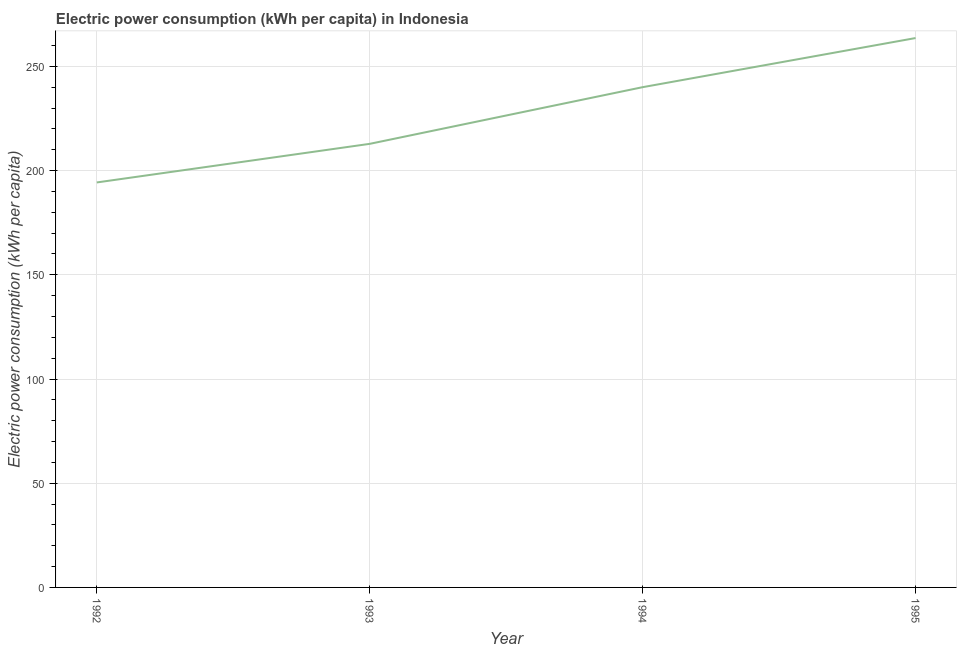What is the electric power consumption in 1995?
Offer a very short reply. 263.59. Across all years, what is the maximum electric power consumption?
Offer a very short reply. 263.59. Across all years, what is the minimum electric power consumption?
Your answer should be very brief. 194.31. In which year was the electric power consumption maximum?
Your answer should be very brief. 1995. What is the sum of the electric power consumption?
Offer a terse response. 910.74. What is the difference between the electric power consumption in 1992 and 1994?
Keep it short and to the point. -45.71. What is the average electric power consumption per year?
Your response must be concise. 227.69. What is the median electric power consumption?
Ensure brevity in your answer.  226.42. What is the ratio of the electric power consumption in 1993 to that in 1995?
Your answer should be very brief. 0.81. Is the difference between the electric power consumption in 1992 and 1994 greater than the difference between any two years?
Provide a succinct answer. No. What is the difference between the highest and the second highest electric power consumption?
Offer a terse response. 23.57. What is the difference between the highest and the lowest electric power consumption?
Offer a very short reply. 69.28. In how many years, is the electric power consumption greater than the average electric power consumption taken over all years?
Your answer should be very brief. 2. Does the electric power consumption monotonically increase over the years?
Provide a short and direct response. Yes. How many lines are there?
Give a very brief answer. 1. What is the difference between two consecutive major ticks on the Y-axis?
Provide a short and direct response. 50. Are the values on the major ticks of Y-axis written in scientific E-notation?
Make the answer very short. No. What is the title of the graph?
Give a very brief answer. Electric power consumption (kWh per capita) in Indonesia. What is the label or title of the Y-axis?
Your answer should be compact. Electric power consumption (kWh per capita). What is the Electric power consumption (kWh per capita) in 1992?
Your answer should be very brief. 194.31. What is the Electric power consumption (kWh per capita) of 1993?
Give a very brief answer. 212.83. What is the Electric power consumption (kWh per capita) of 1994?
Your answer should be compact. 240.02. What is the Electric power consumption (kWh per capita) in 1995?
Offer a terse response. 263.59. What is the difference between the Electric power consumption (kWh per capita) in 1992 and 1993?
Provide a succinct answer. -18.52. What is the difference between the Electric power consumption (kWh per capita) in 1992 and 1994?
Provide a short and direct response. -45.71. What is the difference between the Electric power consumption (kWh per capita) in 1992 and 1995?
Offer a very short reply. -69.28. What is the difference between the Electric power consumption (kWh per capita) in 1993 and 1994?
Provide a succinct answer. -27.19. What is the difference between the Electric power consumption (kWh per capita) in 1993 and 1995?
Your answer should be compact. -50.76. What is the difference between the Electric power consumption (kWh per capita) in 1994 and 1995?
Make the answer very short. -23.57. What is the ratio of the Electric power consumption (kWh per capita) in 1992 to that in 1994?
Keep it short and to the point. 0.81. What is the ratio of the Electric power consumption (kWh per capita) in 1992 to that in 1995?
Give a very brief answer. 0.74. What is the ratio of the Electric power consumption (kWh per capita) in 1993 to that in 1994?
Provide a short and direct response. 0.89. What is the ratio of the Electric power consumption (kWh per capita) in 1993 to that in 1995?
Make the answer very short. 0.81. What is the ratio of the Electric power consumption (kWh per capita) in 1994 to that in 1995?
Make the answer very short. 0.91. 